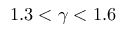<formula> <loc_0><loc_0><loc_500><loc_500>1 . 3 < \gamma < 1 . 6</formula> 